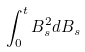Convert formula to latex. <formula><loc_0><loc_0><loc_500><loc_500>\int _ { 0 } ^ { t } B _ { s } ^ { 2 } d B _ { s }</formula> 